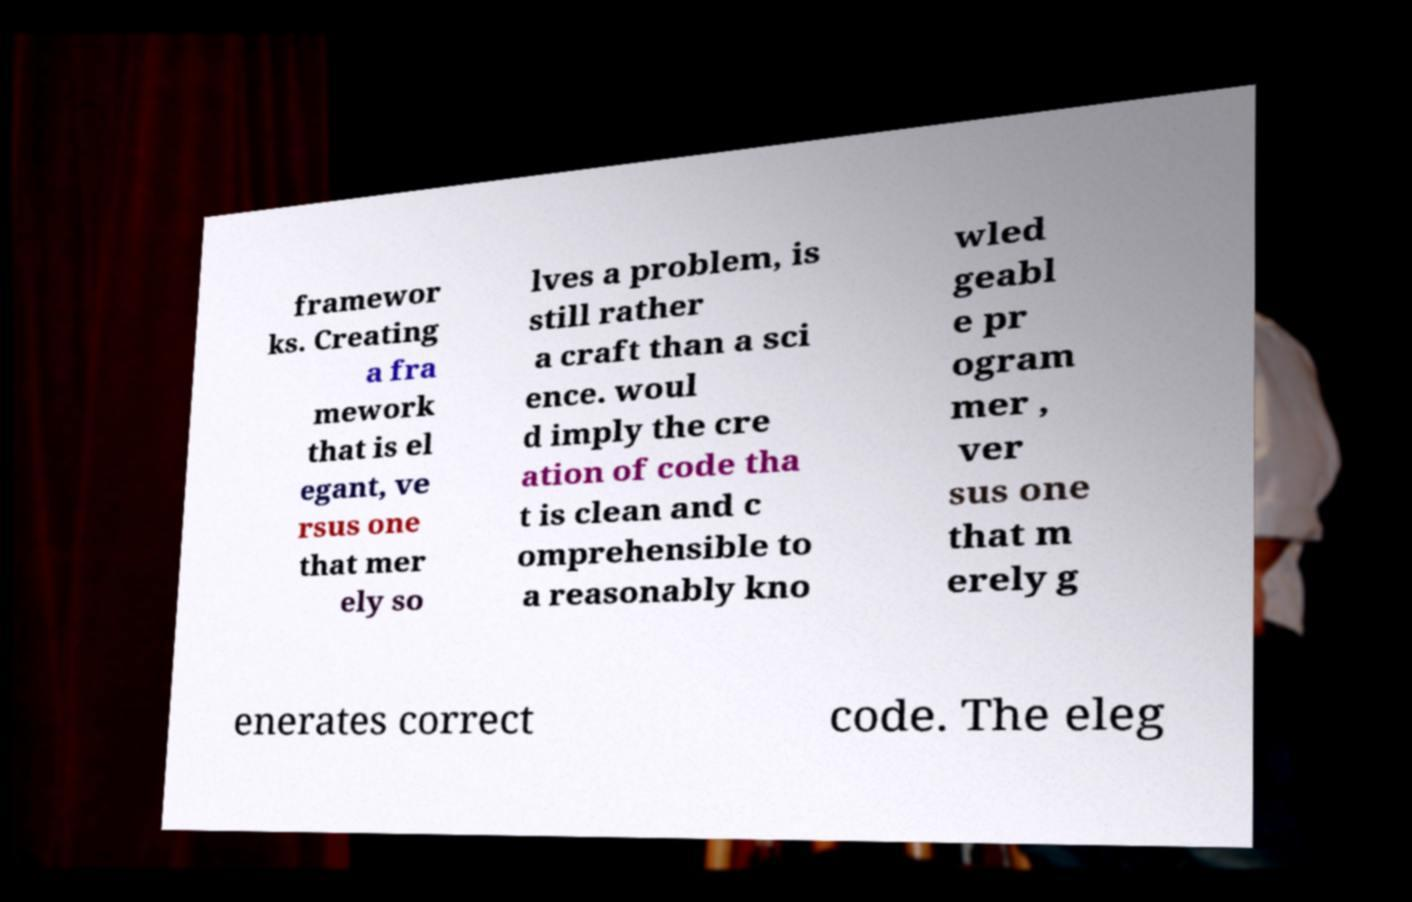What messages or text are displayed in this image? I need them in a readable, typed format. framewor ks. Creating a fra mework that is el egant, ve rsus one that mer ely so lves a problem, is still rather a craft than a sci ence. woul d imply the cre ation of code tha t is clean and c omprehensible to a reasonably kno wled geabl e pr ogram mer , ver sus one that m erely g enerates correct code. The eleg 